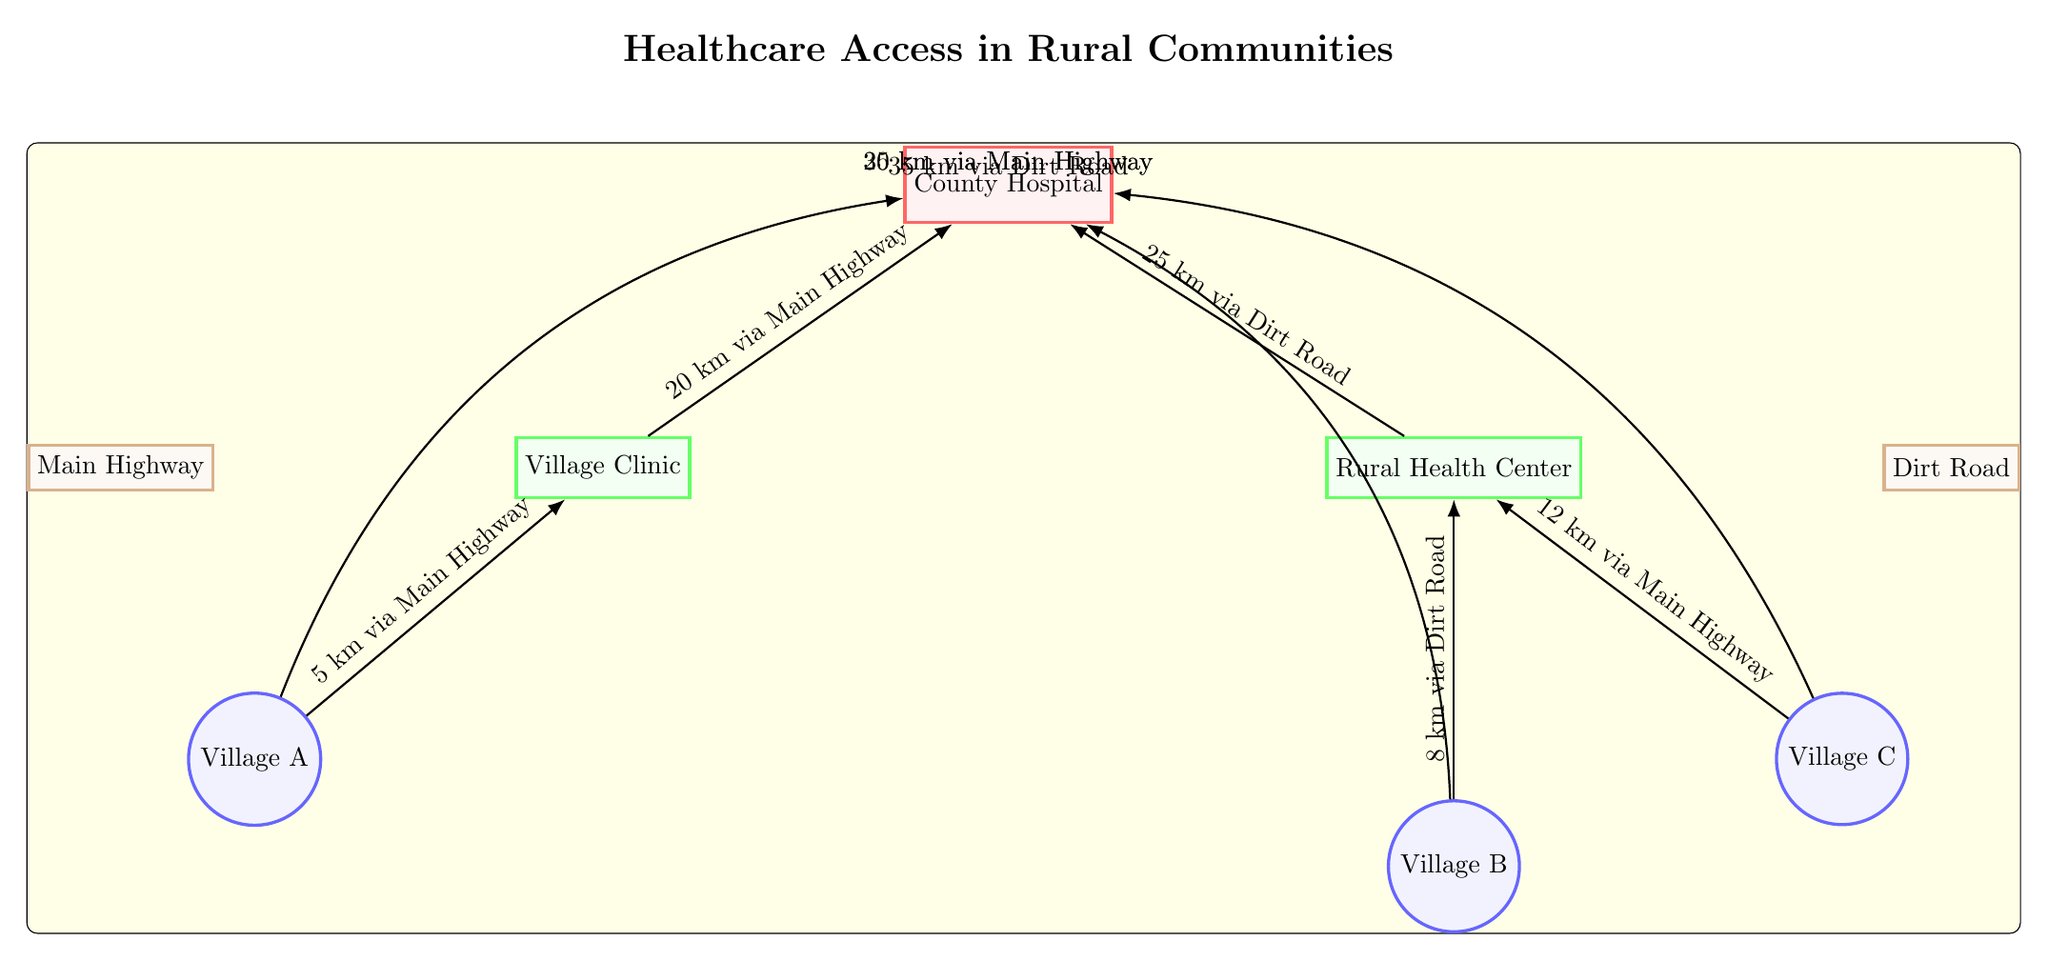What are the different types of nodes in this diagram? The diagram contains four types of nodes: hospitals, clinics, communities, and roads. Each type is represented by a distinct shape and color in the diagram.
Answer: hospitals, clinics, communities, roads How many clinics are shown in the diagram? The diagram displays two clinics: the Village Clinic and the Rural Health Center. This can be counted directly from the node shapes labeled as clinics.
Answer: 2 What is the distance from Village A to the County Hospital? The line connecting Village A to the County Hospital shows a distance of 25 km via Main Highway. This is labeled directly along the connecting line in the diagram.
Answer: 25 km via Main Highway Which community is farthest from a healthcare facility? Comparing the distances of each community to their nearest healthcare facility shows that Village C, which is 30 km away from the County Hospital via Main Highway, is the farthest, as the others have shorter distances.
Answer: Village C How far is the Rural Health Center from the County Hospital? The diagram indicates that the distance from the Rural Health Center to the County Hospital is 25 km via Dirt Road, noted on the connecting line between the two nodes in the diagram.
Answer: 25 km via Dirt Road What is the total distance from Village B to the County Hospital? To determine the total distance, we see that Village B is connected to the Rural Health Center (8 km) and then to the County Hospital (25 km), which makes the total distance 8 km + 25 km = 33 km.
Answer: 33 km Where is Village C located in relation to the Rural Health Center? Village C is located below and to the right of the Rural Health Center in the diagram, connected via a direct line that indicates their relative positioning.
Answer: below right Which road connects Village A to the Village Clinic? The connection from Village A to the Village Clinic uses the Main Highway, as shown on the edge labeled with the distance, indicating the route taken.
Answer: Main Highway How many total connections (edges) are there in this diagram? The diagram illustrates a total of six connections, which can be counted directly from the connecting lines between different nodes.
Answer: 6 